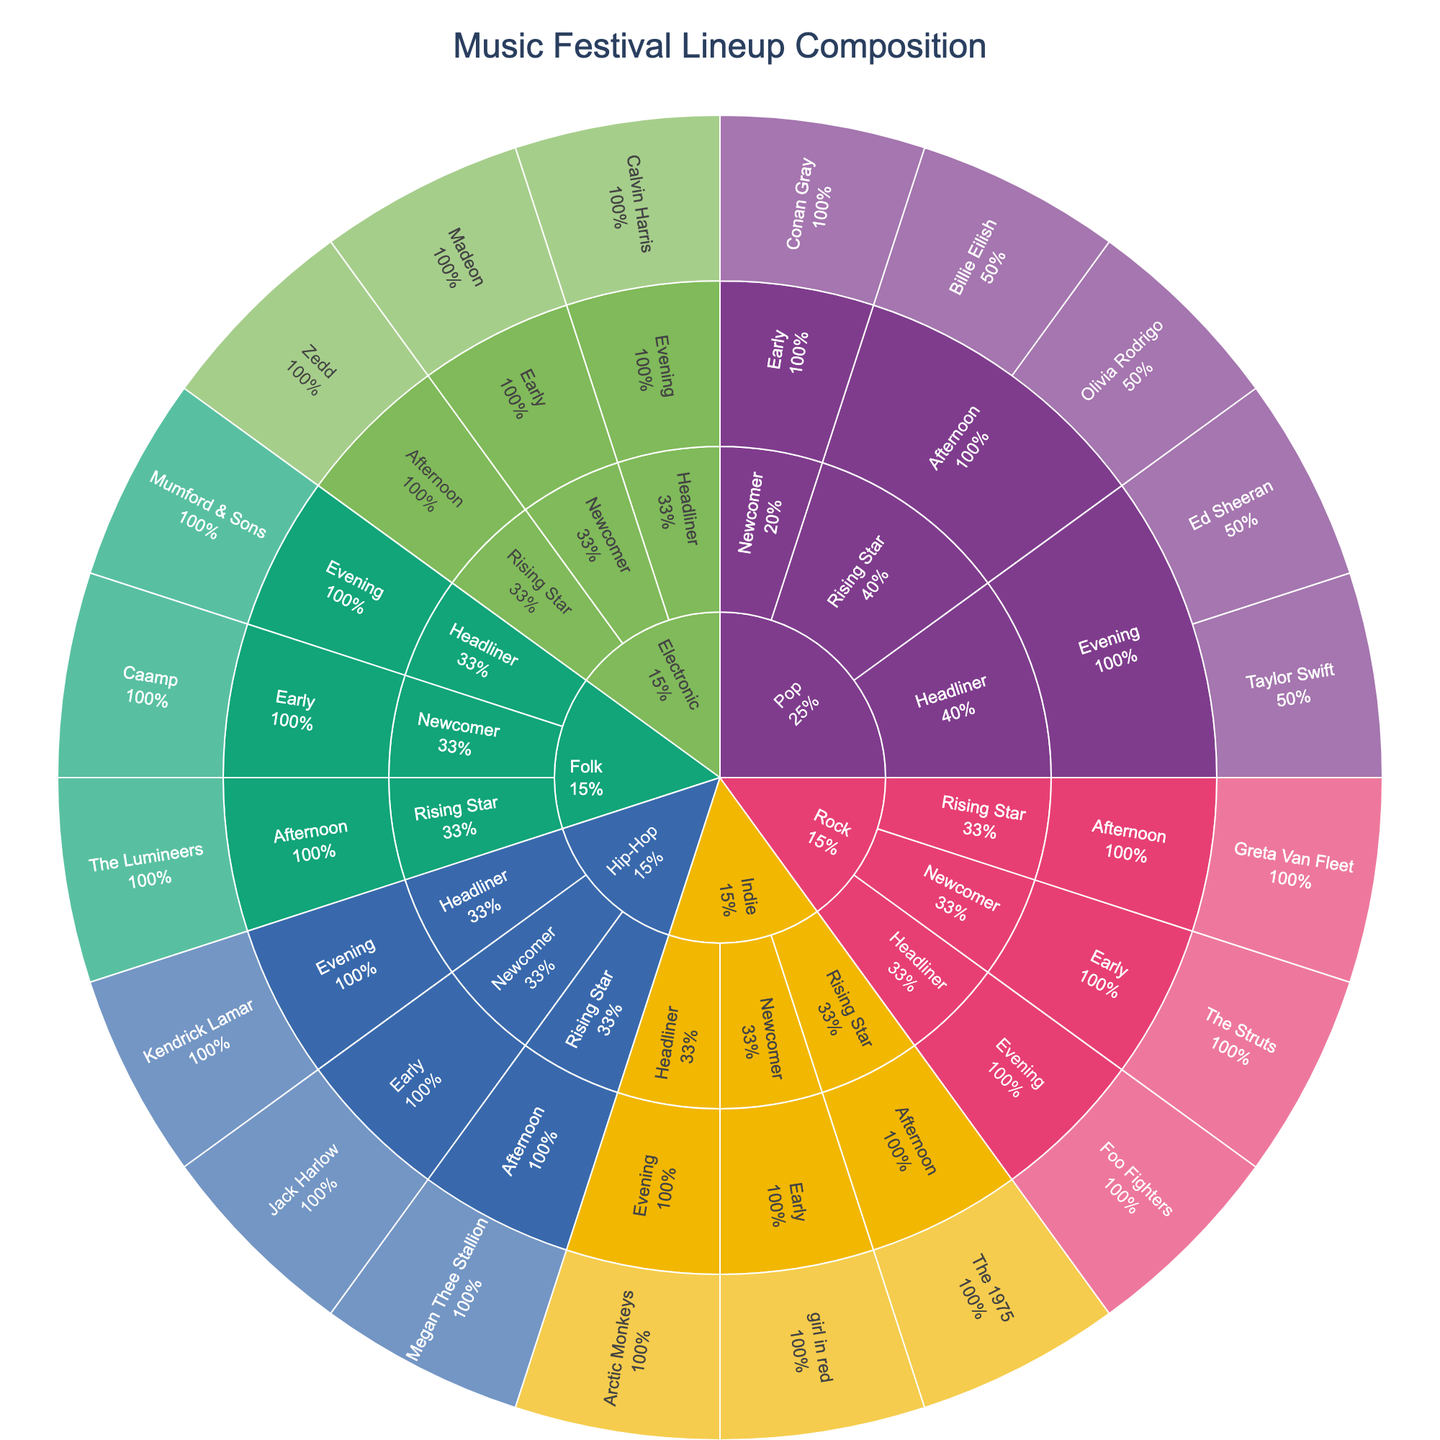What is the title of the figure? The title appears at the top of the figure, clearly stating the main subject being illustrated.
Answer: Music Festival Lineup Composition How many genres are shown in the sunburst plot? The sunburst plot segments genres distinctly in different colors. Counting these unique segments will give the number of genres displayed.
Answer: 5 Which genre has the highest representation in terms of artist popularity? By observing the different segments under each genre, we can look at the size distribution for Headliner, Rising Star, and Newcomer categories within each genre. The genre with the largest segment sizes overall indicates the highest representation in terms of artist popularity.
Answer: Pop How many artists perform in the 'Hip-Hop' genre during the 'Evening' time slot? By navigating through the 'Hip-Hop' genre segment and then to the 'Evening' time slot, the number of segments (artists) present will aid in answering this query.
Answer: 1 Compare the number of 'Rising Star' artists in the 'Pop' genre to those in the 'Rock' genre. Which genre has more? By observing the 'Rising Star' segments within both the 'Pop' and 'Rock' genres, we can count the number of artists in each and see which number is larger.
Answer: Pop In which genre is the 'Headliner' segment largest in proportion to its parent genre segment? Each genre segment contains sub-segments for artist popularity. By examining the proportions of 'Headliner' segments within each genre, the genre with the largest proportional 'Headliner' segment can be identified.
Answer: Indie What proportion of the festival lineup do 'Newcomer' artists make up? To determine the proportion of 'Newcomer' artists, we need to observe the 'Newcomer' segments within all genres and calculate their total percentage compared to all artists.
Answer: 33% Which genre has the lowest number of 'Early' time slot performances? By looking at the 'Early' time slot segments under each genre and counting the number of segments/artists, we can identify the genre with the smallest count.
Answer: Folk Between 'Electronic' and 'Folk' genres, which has more 'Rising Star' artists performing? By examining the 'Rising Star' segments within the 'Electronic' and 'Folk' genres, the segment with the higher count can be identified.
Answer: Electronic How many total artists are performing at the festival? Counting all the artist segments within the sunburst plot will provide the total number of performing artists.
Answer: 20 